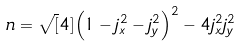<formula> <loc_0><loc_0><loc_500><loc_500>\ n = \sqrt { [ } 4 ] { \left ( 1 - j _ { x } ^ { 2 } - j _ { y } ^ { 2 } \right ) ^ { 2 } - 4 j _ { x } ^ { 2 } j _ { y } ^ { 2 } }</formula> 